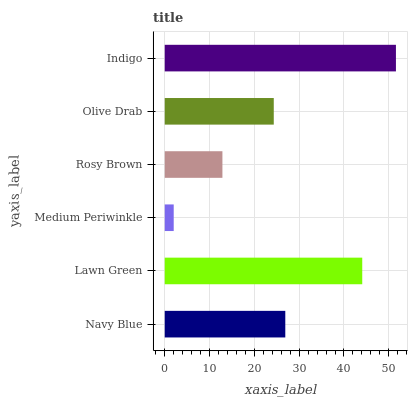Is Medium Periwinkle the minimum?
Answer yes or no. Yes. Is Indigo the maximum?
Answer yes or no. Yes. Is Lawn Green the minimum?
Answer yes or no. No. Is Lawn Green the maximum?
Answer yes or no. No. Is Lawn Green greater than Navy Blue?
Answer yes or no. Yes. Is Navy Blue less than Lawn Green?
Answer yes or no. Yes. Is Navy Blue greater than Lawn Green?
Answer yes or no. No. Is Lawn Green less than Navy Blue?
Answer yes or no. No. Is Navy Blue the high median?
Answer yes or no. Yes. Is Olive Drab the low median?
Answer yes or no. Yes. Is Olive Drab the high median?
Answer yes or no. No. Is Lawn Green the low median?
Answer yes or no. No. 